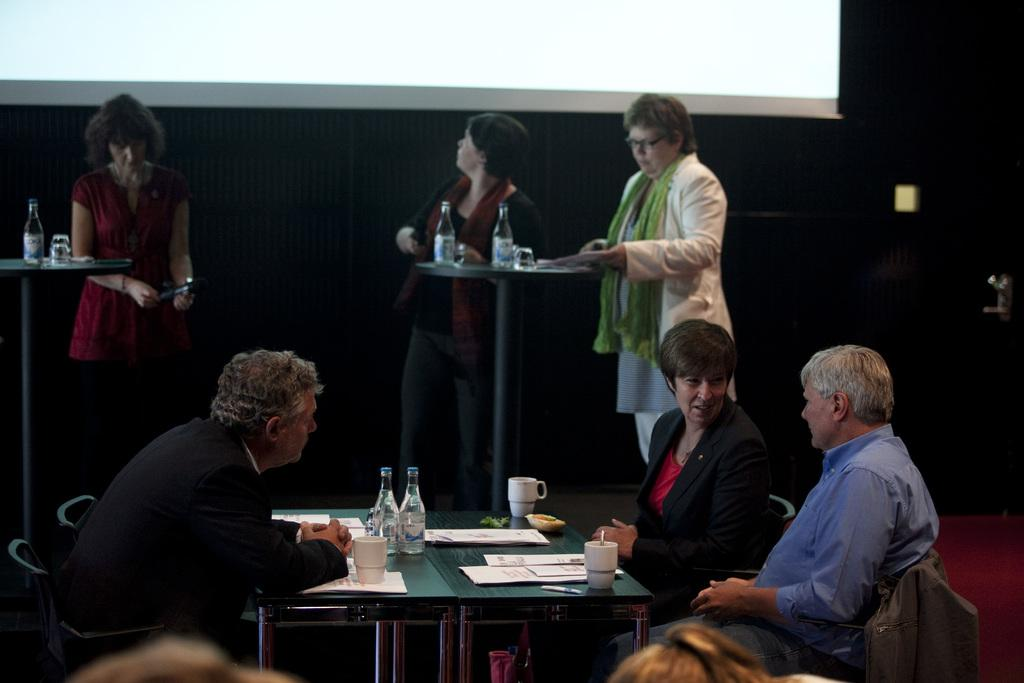What is the main object in the image? There is a screen in the image. What else can be seen in the image besides the screen? There are people standing, chairs, and a table in the image. What items are on the table? There are bottles, cups, plates, and papers on the table. What type of leather material is covering the orange in the image? There is no orange or leather material present in the image. 